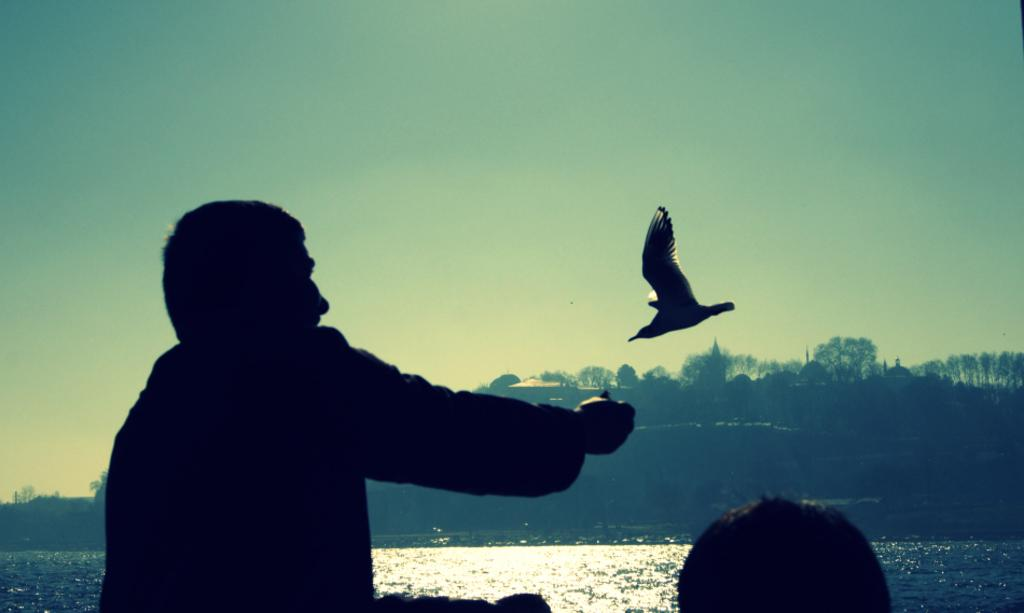How many people are in the foreground of the image? There are two persons in the foreground of the image. What can be seen in the background of the image? There are trees and houses in the background of the image. What type of animal is flying in the air in the image? There is a bird in the air in the image. What is visible at the top of the image? The sky is visible at the top of the image. What type of doll is sitting inside the tent in the image? There is no doll or tent present in the image. What knowledge can be gained from the image about the bird's migration patterns? The image does not provide any information about the bird's migration patterns. 